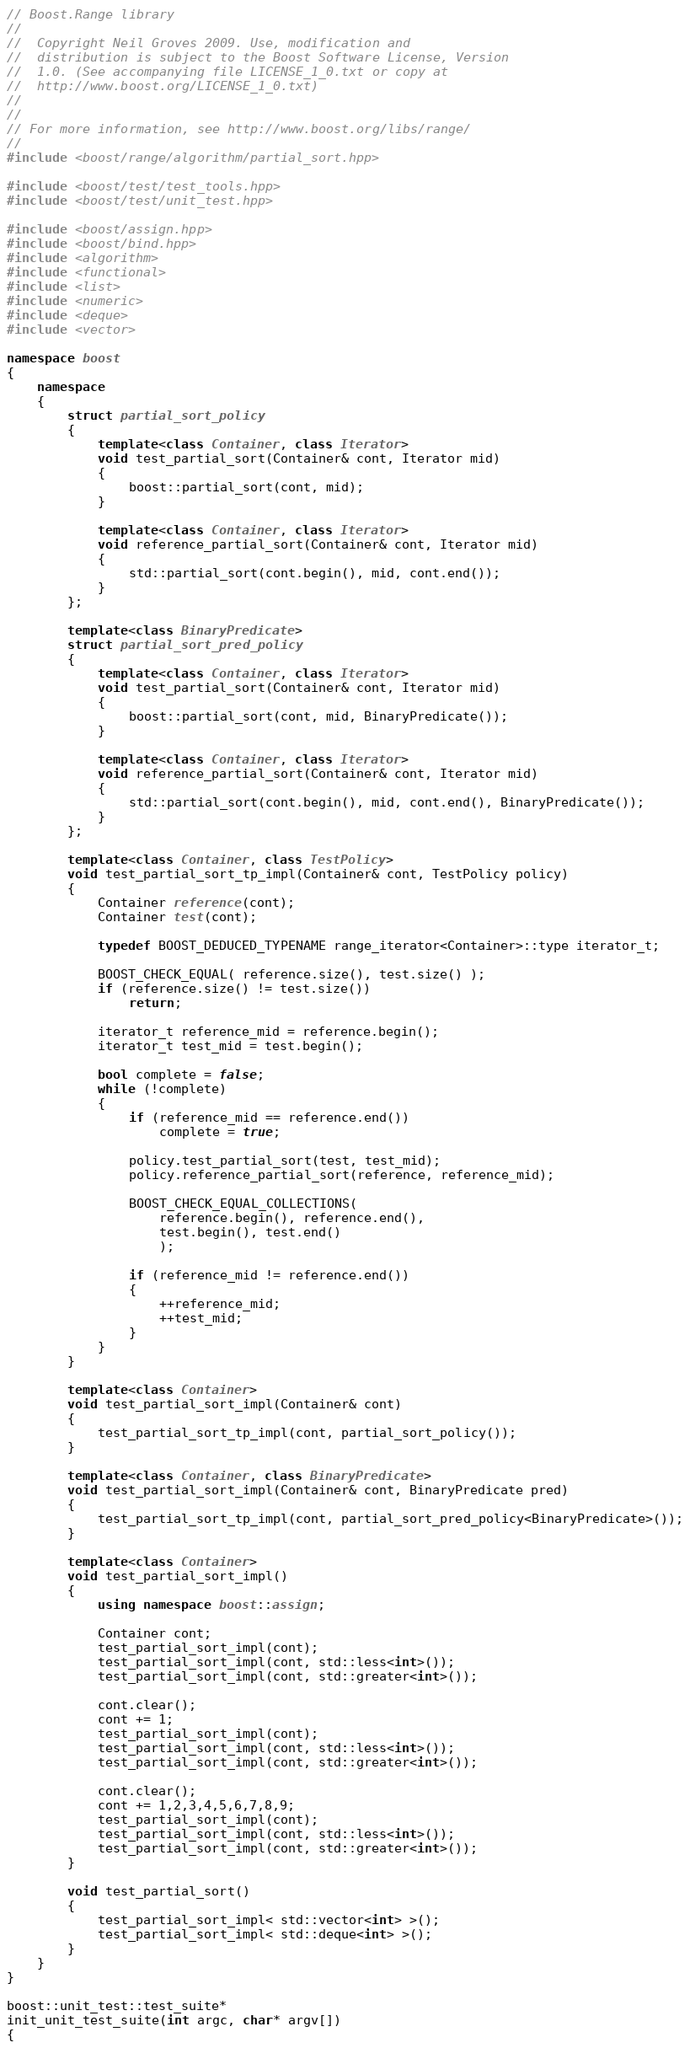<code> <loc_0><loc_0><loc_500><loc_500><_C++_>// Boost.Range library
//
//  Copyright Neil Groves 2009. Use, modification and
//  distribution is subject to the Boost Software License, Version
//  1.0. (See accompanying file LICENSE_1_0.txt or copy at
//  http://www.boost.org/LICENSE_1_0.txt)
//
//
// For more information, see http://www.boost.org/libs/range/
//
#include <boost/range/algorithm/partial_sort.hpp>

#include <boost/test/test_tools.hpp>
#include <boost/test/unit_test.hpp>

#include <boost/assign.hpp>
#include <boost/bind.hpp>
#include <algorithm>
#include <functional>
#include <list>
#include <numeric>
#include <deque>
#include <vector>

namespace boost
{
    namespace
    {
        struct partial_sort_policy
        {
            template<class Container, class Iterator>
            void test_partial_sort(Container& cont, Iterator mid)
            {
                boost::partial_sort(cont, mid);
            }

            template<class Container, class Iterator>
            void reference_partial_sort(Container& cont, Iterator mid)
            {
                std::partial_sort(cont.begin(), mid, cont.end());
            }
        };

        template<class BinaryPredicate>
        struct partial_sort_pred_policy
        {
            template<class Container, class Iterator>
            void test_partial_sort(Container& cont, Iterator mid)
            {
                boost::partial_sort(cont, mid, BinaryPredicate());
            }

            template<class Container, class Iterator>
            void reference_partial_sort(Container& cont, Iterator mid)
            {
                std::partial_sort(cont.begin(), mid, cont.end(), BinaryPredicate());
            }
        };

        template<class Container, class TestPolicy>
        void test_partial_sort_tp_impl(Container& cont, TestPolicy policy)
        {
            Container reference(cont);
            Container test(cont);

            typedef BOOST_DEDUCED_TYPENAME range_iterator<Container>::type iterator_t;

            BOOST_CHECK_EQUAL( reference.size(), test.size() );
            if (reference.size() != test.size())
                return;

            iterator_t reference_mid = reference.begin();
            iterator_t test_mid = test.begin();

            bool complete = false;
            while (!complete)
            {
                if (reference_mid == reference.end())
                    complete = true;

                policy.test_partial_sort(test, test_mid);
                policy.reference_partial_sort(reference, reference_mid);

                BOOST_CHECK_EQUAL_COLLECTIONS(
                    reference.begin(), reference.end(),
                    test.begin(), test.end()
                    );

                if (reference_mid != reference.end())
                {
                    ++reference_mid;
                    ++test_mid;
                }
            }
        }

        template<class Container>
        void test_partial_sort_impl(Container& cont)
        {
            test_partial_sort_tp_impl(cont, partial_sort_policy());
        }

        template<class Container, class BinaryPredicate>
        void test_partial_sort_impl(Container& cont, BinaryPredicate pred)
        {
            test_partial_sort_tp_impl(cont, partial_sort_pred_policy<BinaryPredicate>());
        }

        template<class Container>
        void test_partial_sort_impl()
        {
            using namespace boost::assign;

            Container cont;
            test_partial_sort_impl(cont);
            test_partial_sort_impl(cont, std::less<int>());
            test_partial_sort_impl(cont, std::greater<int>());

            cont.clear();
            cont += 1;
            test_partial_sort_impl(cont);
            test_partial_sort_impl(cont, std::less<int>());
            test_partial_sort_impl(cont, std::greater<int>());

            cont.clear();
            cont += 1,2,3,4,5,6,7,8,9;
            test_partial_sort_impl(cont);
            test_partial_sort_impl(cont, std::less<int>());
            test_partial_sort_impl(cont, std::greater<int>());
        }

        void test_partial_sort()
        {
            test_partial_sort_impl< std::vector<int> >();
            test_partial_sort_impl< std::deque<int> >();
        }
    }
}

boost::unit_test::test_suite*
init_unit_test_suite(int argc, char* argv[])
{</code> 